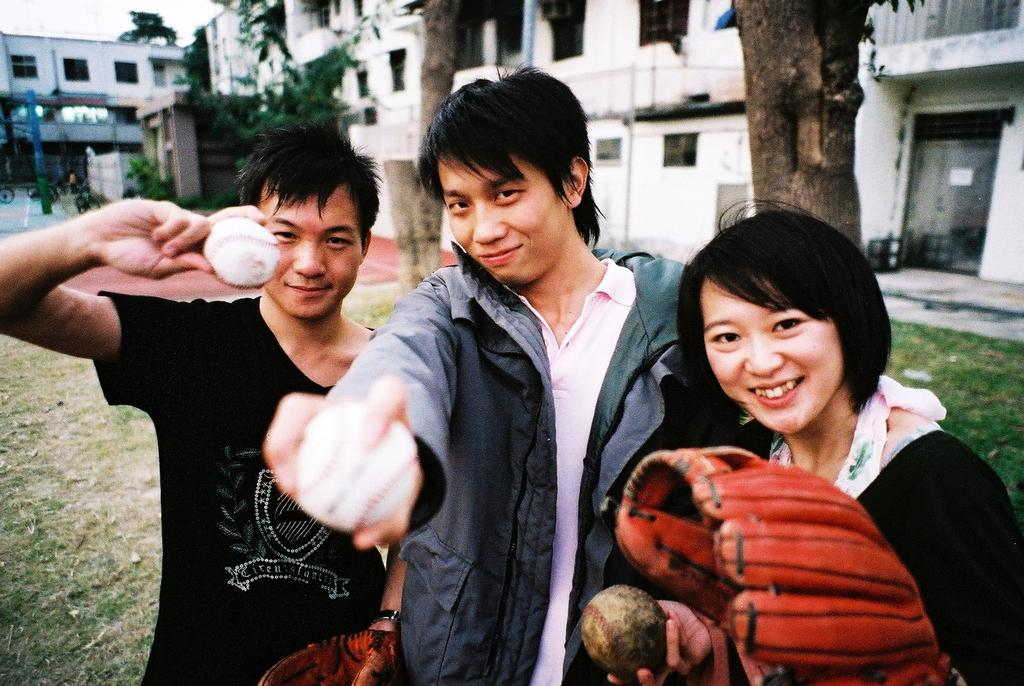What is the main subject of the image? The main subject of the image is people. What are the people holding in their hands? The people are holding balls in their hands. What can be seen in the background of the image? There are buildings and trees in the background of the image. What type of furniture can be seen in the image? There is no furniture present in the image. What kind of wood is used to make the goat in the image? There is no goat present in the image, so it is not possible to determine the type of wood used. 